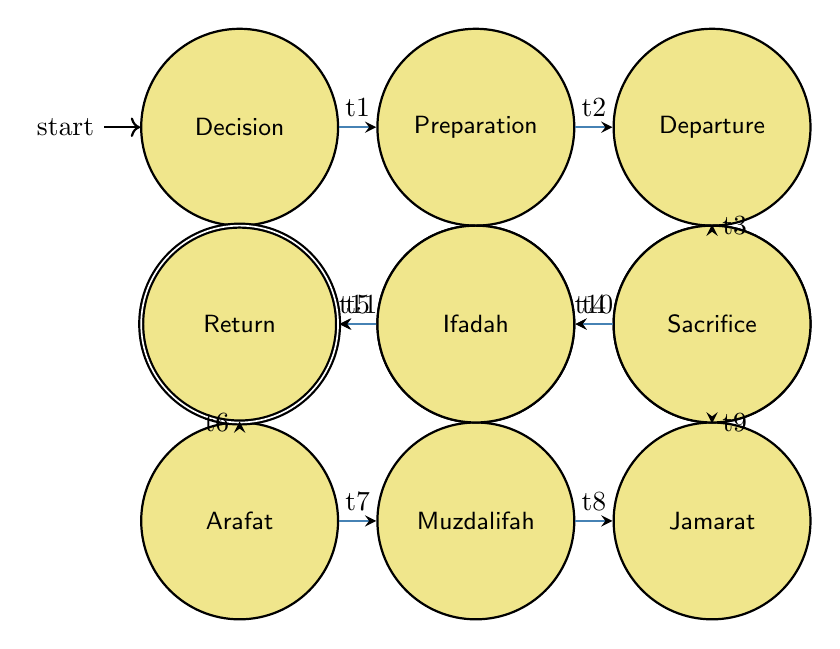What is the first node in the diagram? The first node, also known as the initial state, is marked clearly and represents the first decision point. It is labeled "Decision to Perform Hajj."
Answer: Decision to Perform Hajj How many nodes are present in the diagram? To find the total number of nodes, we count each distinct node listed in the diagram. There are twelve nodes identified in the data provided.
Answer: 12 What is the last node in the sequence? The last node, or final state, can be found at the end of the transition flow. It is labeled "Return Home."
Answer: Return Home What transition occurs after "Sa'i Between Safa and Marwah"? To find the transition after "Sa'i Between Safa and Marwah," we look at the directed edges from that node. The next transition leads to "Standing at Arafat."
Answer: Standing at Arafat What is the significance of the "Rami al-Jamarat" node? The "Rami al-Jamarat" node represents a critical ritual of stoning, symbolizing the rejection of evil. This makes it significant in the context of the Hajj journey.
Answer: Rejection of evil Which node immediately follows "Arrival in Makkah"? By examining the directed edges in the diagram, we identify the node that comes after "Arrival in Makkah." It leads directly to "Performing Tawaf."
Answer: Performing Tawaf What does the transition labeled "t5" represent? The transition labeled "t5" connects the nodes "Performing Tawaf" and "Sa'i Between Safa and Marwah." This transition indicates the movement between these two significant rituals.
Answer: Transition from Tawaf to Sa'i What phase comes directly before "Standing at Arafat"? To determine which phase precedes "Standing at Arafat," we look for the node that directly points to it in the flow. This node is "Sa'i Between Safa and Marwah."
Answer: Sa'i Between Safa and Marwah What do the nodes represent in the context of Hajj? Each node represents a significant step or ritual in the spiritual journey of performing Hajj, showing the essential phases from the decision to the return home.
Answer: Significant steps in Hajj 